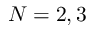Convert formula to latex. <formula><loc_0><loc_0><loc_500><loc_500>N = 2 , 3</formula> 